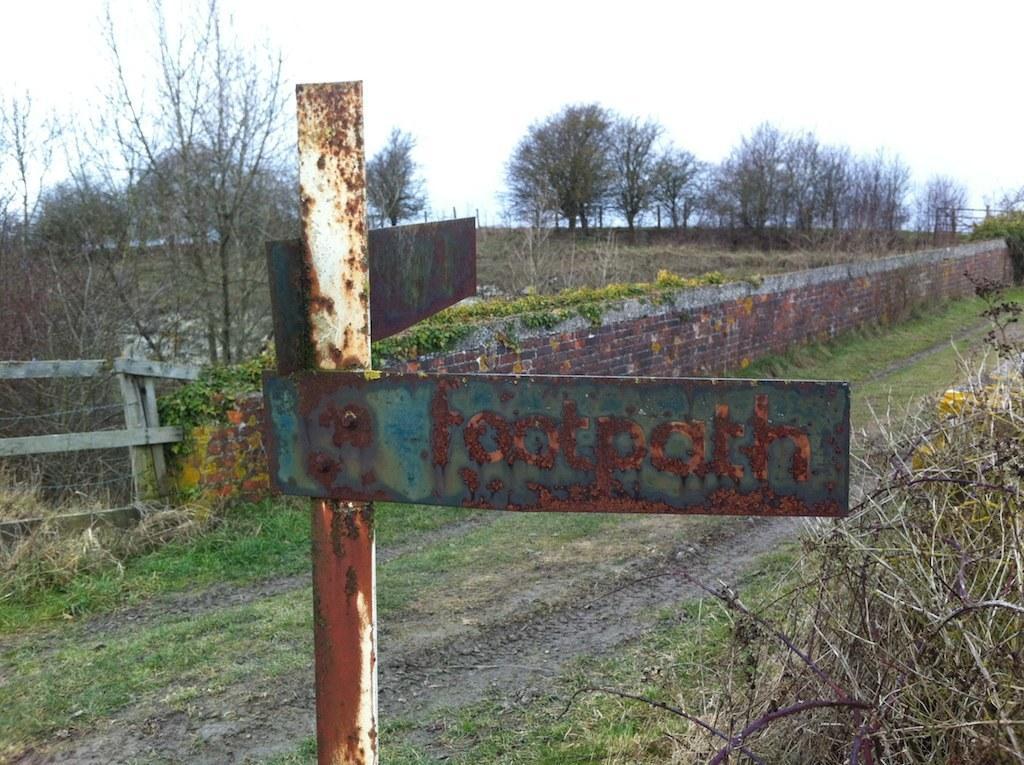In one or two sentences, can you explain what this image depicts? In this picture we can see a pole and a board in the front, at the bottom there is grass, on the left side there is fencing, we can see a wall in the middle, in the background there are some trees, we can see the sky at the top of the picture. 